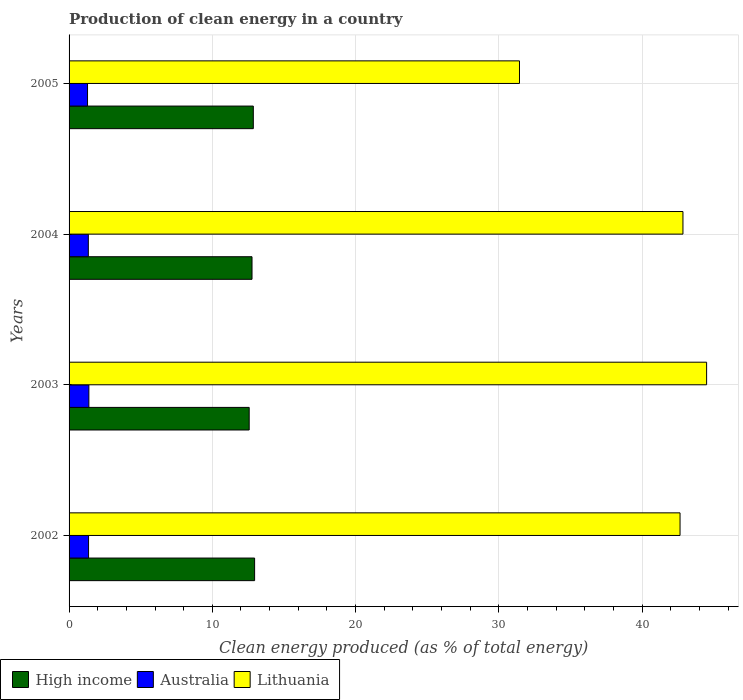How many groups of bars are there?
Provide a short and direct response. 4. Are the number of bars per tick equal to the number of legend labels?
Offer a terse response. Yes. What is the label of the 4th group of bars from the top?
Keep it short and to the point. 2002. In how many cases, is the number of bars for a given year not equal to the number of legend labels?
Make the answer very short. 0. What is the percentage of clean energy produced in High income in 2004?
Offer a terse response. 12.77. Across all years, what is the maximum percentage of clean energy produced in Lithuania?
Offer a very short reply. 44.51. Across all years, what is the minimum percentage of clean energy produced in Lithuania?
Make the answer very short. 31.44. In which year was the percentage of clean energy produced in High income maximum?
Your answer should be very brief. 2002. In which year was the percentage of clean energy produced in Lithuania minimum?
Offer a terse response. 2005. What is the total percentage of clean energy produced in Lithuania in the graph?
Your response must be concise. 161.45. What is the difference between the percentage of clean energy produced in High income in 2004 and that in 2005?
Your response must be concise. -0.09. What is the difference between the percentage of clean energy produced in Lithuania in 2004 and the percentage of clean energy produced in High income in 2003?
Provide a succinct answer. 30.28. What is the average percentage of clean energy produced in Australia per year?
Provide a short and direct response. 1.34. In the year 2003, what is the difference between the percentage of clean energy produced in Lithuania and percentage of clean energy produced in Australia?
Your answer should be compact. 43.12. In how many years, is the percentage of clean energy produced in Lithuania greater than 20 %?
Your answer should be compact. 4. What is the ratio of the percentage of clean energy produced in Australia in 2003 to that in 2004?
Offer a very short reply. 1.03. What is the difference between the highest and the second highest percentage of clean energy produced in Australia?
Provide a short and direct response. 0.02. What is the difference between the highest and the lowest percentage of clean energy produced in Lithuania?
Your response must be concise. 13.06. In how many years, is the percentage of clean energy produced in Lithuania greater than the average percentage of clean energy produced in Lithuania taken over all years?
Your response must be concise. 3. Is the sum of the percentage of clean energy produced in High income in 2002 and 2003 greater than the maximum percentage of clean energy produced in Australia across all years?
Provide a succinct answer. Yes. What does the 1st bar from the top in 2004 represents?
Ensure brevity in your answer.  Lithuania. What does the 1st bar from the bottom in 2004 represents?
Offer a very short reply. High income. How many bars are there?
Your response must be concise. 12. Does the graph contain grids?
Offer a very short reply. Yes. How many legend labels are there?
Provide a succinct answer. 3. How are the legend labels stacked?
Ensure brevity in your answer.  Horizontal. What is the title of the graph?
Your response must be concise. Production of clean energy in a country. Does "Zimbabwe" appear as one of the legend labels in the graph?
Your answer should be very brief. No. What is the label or title of the X-axis?
Offer a very short reply. Clean energy produced (as % of total energy). What is the label or title of the Y-axis?
Offer a terse response. Years. What is the Clean energy produced (as % of total energy) in High income in 2002?
Offer a terse response. 12.95. What is the Clean energy produced (as % of total energy) of Australia in 2002?
Your answer should be very brief. 1.36. What is the Clean energy produced (as % of total energy) of Lithuania in 2002?
Give a very brief answer. 42.65. What is the Clean energy produced (as % of total energy) in High income in 2003?
Offer a terse response. 12.57. What is the Clean energy produced (as % of total energy) in Australia in 2003?
Ensure brevity in your answer.  1.38. What is the Clean energy produced (as % of total energy) in Lithuania in 2003?
Keep it short and to the point. 44.51. What is the Clean energy produced (as % of total energy) in High income in 2004?
Make the answer very short. 12.77. What is the Clean energy produced (as % of total energy) in Australia in 2004?
Offer a terse response. 1.34. What is the Clean energy produced (as % of total energy) of Lithuania in 2004?
Give a very brief answer. 42.85. What is the Clean energy produced (as % of total energy) in High income in 2005?
Your response must be concise. 12.86. What is the Clean energy produced (as % of total energy) in Australia in 2005?
Your answer should be very brief. 1.29. What is the Clean energy produced (as % of total energy) in Lithuania in 2005?
Make the answer very short. 31.44. Across all years, what is the maximum Clean energy produced (as % of total energy) in High income?
Keep it short and to the point. 12.95. Across all years, what is the maximum Clean energy produced (as % of total energy) in Australia?
Your answer should be very brief. 1.38. Across all years, what is the maximum Clean energy produced (as % of total energy) of Lithuania?
Your response must be concise. 44.51. Across all years, what is the minimum Clean energy produced (as % of total energy) in High income?
Provide a short and direct response. 12.57. Across all years, what is the minimum Clean energy produced (as % of total energy) in Australia?
Give a very brief answer. 1.29. Across all years, what is the minimum Clean energy produced (as % of total energy) in Lithuania?
Provide a short and direct response. 31.44. What is the total Clean energy produced (as % of total energy) of High income in the graph?
Your response must be concise. 51.16. What is the total Clean energy produced (as % of total energy) of Australia in the graph?
Keep it short and to the point. 5.38. What is the total Clean energy produced (as % of total energy) of Lithuania in the graph?
Ensure brevity in your answer.  161.45. What is the difference between the Clean energy produced (as % of total energy) in High income in 2002 and that in 2003?
Your answer should be compact. 0.38. What is the difference between the Clean energy produced (as % of total energy) in Australia in 2002 and that in 2003?
Offer a terse response. -0.02. What is the difference between the Clean energy produced (as % of total energy) in Lithuania in 2002 and that in 2003?
Offer a very short reply. -1.85. What is the difference between the Clean energy produced (as % of total energy) of High income in 2002 and that in 2004?
Your answer should be compact. 0.18. What is the difference between the Clean energy produced (as % of total energy) of Australia in 2002 and that in 2004?
Offer a very short reply. 0.02. What is the difference between the Clean energy produced (as % of total energy) of Lithuania in 2002 and that in 2004?
Offer a terse response. -0.2. What is the difference between the Clean energy produced (as % of total energy) of High income in 2002 and that in 2005?
Give a very brief answer. 0.09. What is the difference between the Clean energy produced (as % of total energy) of Australia in 2002 and that in 2005?
Give a very brief answer. 0.07. What is the difference between the Clean energy produced (as % of total energy) of Lithuania in 2002 and that in 2005?
Give a very brief answer. 11.21. What is the difference between the Clean energy produced (as % of total energy) of High income in 2003 and that in 2004?
Make the answer very short. -0.2. What is the difference between the Clean energy produced (as % of total energy) of Australia in 2003 and that in 2004?
Provide a succinct answer. 0.04. What is the difference between the Clean energy produced (as % of total energy) in Lithuania in 2003 and that in 2004?
Offer a very short reply. 1.65. What is the difference between the Clean energy produced (as % of total energy) in High income in 2003 and that in 2005?
Provide a short and direct response. -0.29. What is the difference between the Clean energy produced (as % of total energy) of Australia in 2003 and that in 2005?
Keep it short and to the point. 0.09. What is the difference between the Clean energy produced (as % of total energy) in Lithuania in 2003 and that in 2005?
Offer a terse response. 13.06. What is the difference between the Clean energy produced (as % of total energy) in High income in 2004 and that in 2005?
Your answer should be compact. -0.09. What is the difference between the Clean energy produced (as % of total energy) of Australia in 2004 and that in 2005?
Provide a short and direct response. 0.06. What is the difference between the Clean energy produced (as % of total energy) in Lithuania in 2004 and that in 2005?
Your answer should be compact. 11.41. What is the difference between the Clean energy produced (as % of total energy) of High income in 2002 and the Clean energy produced (as % of total energy) of Australia in 2003?
Give a very brief answer. 11.57. What is the difference between the Clean energy produced (as % of total energy) in High income in 2002 and the Clean energy produced (as % of total energy) in Lithuania in 2003?
Ensure brevity in your answer.  -31.55. What is the difference between the Clean energy produced (as % of total energy) in Australia in 2002 and the Clean energy produced (as % of total energy) in Lithuania in 2003?
Your answer should be compact. -43.15. What is the difference between the Clean energy produced (as % of total energy) of High income in 2002 and the Clean energy produced (as % of total energy) of Australia in 2004?
Make the answer very short. 11.61. What is the difference between the Clean energy produced (as % of total energy) in High income in 2002 and the Clean energy produced (as % of total energy) in Lithuania in 2004?
Keep it short and to the point. -29.9. What is the difference between the Clean energy produced (as % of total energy) of Australia in 2002 and the Clean energy produced (as % of total energy) of Lithuania in 2004?
Give a very brief answer. -41.49. What is the difference between the Clean energy produced (as % of total energy) in High income in 2002 and the Clean energy produced (as % of total energy) in Australia in 2005?
Give a very brief answer. 11.66. What is the difference between the Clean energy produced (as % of total energy) of High income in 2002 and the Clean energy produced (as % of total energy) of Lithuania in 2005?
Offer a very short reply. -18.49. What is the difference between the Clean energy produced (as % of total energy) in Australia in 2002 and the Clean energy produced (as % of total energy) in Lithuania in 2005?
Provide a short and direct response. -30.08. What is the difference between the Clean energy produced (as % of total energy) of High income in 2003 and the Clean energy produced (as % of total energy) of Australia in 2004?
Your answer should be compact. 11.23. What is the difference between the Clean energy produced (as % of total energy) in High income in 2003 and the Clean energy produced (as % of total energy) in Lithuania in 2004?
Your answer should be compact. -30.28. What is the difference between the Clean energy produced (as % of total energy) in Australia in 2003 and the Clean energy produced (as % of total energy) in Lithuania in 2004?
Your answer should be very brief. -41.47. What is the difference between the Clean energy produced (as % of total energy) of High income in 2003 and the Clean energy produced (as % of total energy) of Australia in 2005?
Provide a short and direct response. 11.28. What is the difference between the Clean energy produced (as % of total energy) of High income in 2003 and the Clean energy produced (as % of total energy) of Lithuania in 2005?
Offer a terse response. -18.87. What is the difference between the Clean energy produced (as % of total energy) in Australia in 2003 and the Clean energy produced (as % of total energy) in Lithuania in 2005?
Your answer should be compact. -30.06. What is the difference between the Clean energy produced (as % of total energy) of High income in 2004 and the Clean energy produced (as % of total energy) of Australia in 2005?
Your answer should be compact. 11.48. What is the difference between the Clean energy produced (as % of total energy) of High income in 2004 and the Clean energy produced (as % of total energy) of Lithuania in 2005?
Ensure brevity in your answer.  -18.67. What is the difference between the Clean energy produced (as % of total energy) of Australia in 2004 and the Clean energy produced (as % of total energy) of Lithuania in 2005?
Your response must be concise. -30.1. What is the average Clean energy produced (as % of total energy) in High income per year?
Provide a short and direct response. 12.79. What is the average Clean energy produced (as % of total energy) of Australia per year?
Keep it short and to the point. 1.34. What is the average Clean energy produced (as % of total energy) of Lithuania per year?
Provide a short and direct response. 40.36. In the year 2002, what is the difference between the Clean energy produced (as % of total energy) of High income and Clean energy produced (as % of total energy) of Australia?
Your answer should be compact. 11.59. In the year 2002, what is the difference between the Clean energy produced (as % of total energy) in High income and Clean energy produced (as % of total energy) in Lithuania?
Ensure brevity in your answer.  -29.7. In the year 2002, what is the difference between the Clean energy produced (as % of total energy) in Australia and Clean energy produced (as % of total energy) in Lithuania?
Make the answer very short. -41.29. In the year 2003, what is the difference between the Clean energy produced (as % of total energy) in High income and Clean energy produced (as % of total energy) in Australia?
Provide a short and direct response. 11.19. In the year 2003, what is the difference between the Clean energy produced (as % of total energy) in High income and Clean energy produced (as % of total energy) in Lithuania?
Your answer should be compact. -31.93. In the year 2003, what is the difference between the Clean energy produced (as % of total energy) in Australia and Clean energy produced (as % of total energy) in Lithuania?
Provide a short and direct response. -43.12. In the year 2004, what is the difference between the Clean energy produced (as % of total energy) of High income and Clean energy produced (as % of total energy) of Australia?
Offer a terse response. 11.43. In the year 2004, what is the difference between the Clean energy produced (as % of total energy) in High income and Clean energy produced (as % of total energy) in Lithuania?
Keep it short and to the point. -30.08. In the year 2004, what is the difference between the Clean energy produced (as % of total energy) in Australia and Clean energy produced (as % of total energy) in Lithuania?
Your answer should be compact. -41.51. In the year 2005, what is the difference between the Clean energy produced (as % of total energy) of High income and Clean energy produced (as % of total energy) of Australia?
Provide a short and direct response. 11.57. In the year 2005, what is the difference between the Clean energy produced (as % of total energy) in High income and Clean energy produced (as % of total energy) in Lithuania?
Your response must be concise. -18.58. In the year 2005, what is the difference between the Clean energy produced (as % of total energy) of Australia and Clean energy produced (as % of total energy) of Lithuania?
Offer a very short reply. -30.15. What is the ratio of the Clean energy produced (as % of total energy) of High income in 2002 to that in 2003?
Ensure brevity in your answer.  1.03. What is the ratio of the Clean energy produced (as % of total energy) in Lithuania in 2002 to that in 2003?
Your response must be concise. 0.96. What is the ratio of the Clean energy produced (as % of total energy) of High income in 2002 to that in 2004?
Offer a terse response. 1.01. What is the ratio of the Clean energy produced (as % of total energy) of Australia in 2002 to that in 2004?
Provide a succinct answer. 1.01. What is the ratio of the Clean energy produced (as % of total energy) in Australia in 2002 to that in 2005?
Your answer should be very brief. 1.06. What is the ratio of the Clean energy produced (as % of total energy) in Lithuania in 2002 to that in 2005?
Provide a short and direct response. 1.36. What is the ratio of the Clean energy produced (as % of total energy) in High income in 2003 to that in 2004?
Offer a terse response. 0.98. What is the ratio of the Clean energy produced (as % of total energy) of Australia in 2003 to that in 2004?
Your answer should be very brief. 1.03. What is the ratio of the Clean energy produced (as % of total energy) of High income in 2003 to that in 2005?
Ensure brevity in your answer.  0.98. What is the ratio of the Clean energy produced (as % of total energy) in Australia in 2003 to that in 2005?
Give a very brief answer. 1.07. What is the ratio of the Clean energy produced (as % of total energy) in Lithuania in 2003 to that in 2005?
Ensure brevity in your answer.  1.42. What is the ratio of the Clean energy produced (as % of total energy) in Australia in 2004 to that in 2005?
Your response must be concise. 1.04. What is the ratio of the Clean energy produced (as % of total energy) of Lithuania in 2004 to that in 2005?
Make the answer very short. 1.36. What is the difference between the highest and the second highest Clean energy produced (as % of total energy) of High income?
Offer a very short reply. 0.09. What is the difference between the highest and the second highest Clean energy produced (as % of total energy) in Australia?
Offer a very short reply. 0.02. What is the difference between the highest and the second highest Clean energy produced (as % of total energy) of Lithuania?
Provide a short and direct response. 1.65. What is the difference between the highest and the lowest Clean energy produced (as % of total energy) in High income?
Offer a terse response. 0.38. What is the difference between the highest and the lowest Clean energy produced (as % of total energy) of Australia?
Your response must be concise. 0.09. What is the difference between the highest and the lowest Clean energy produced (as % of total energy) of Lithuania?
Provide a succinct answer. 13.06. 